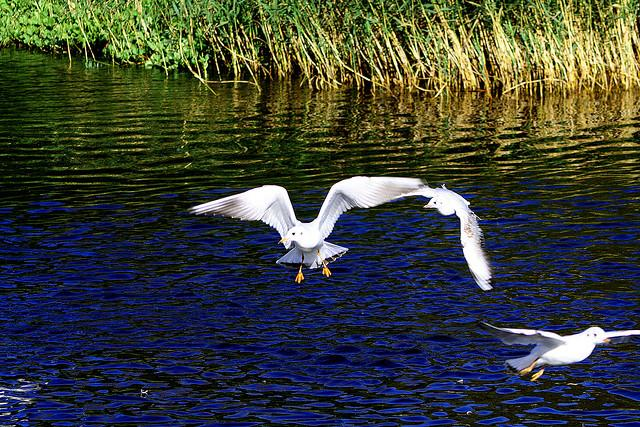What is in the air?

Choices:
A) birds
B) balloons
C) kites
D) airplane birds 